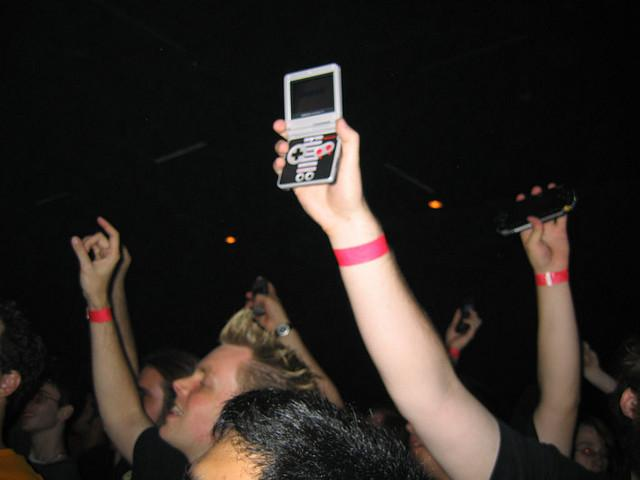The bottom portion of the screen that is furthest to the front looks like what video game controller? Please explain your reasoning. nes. An nes was grey, white and black with the same style. 